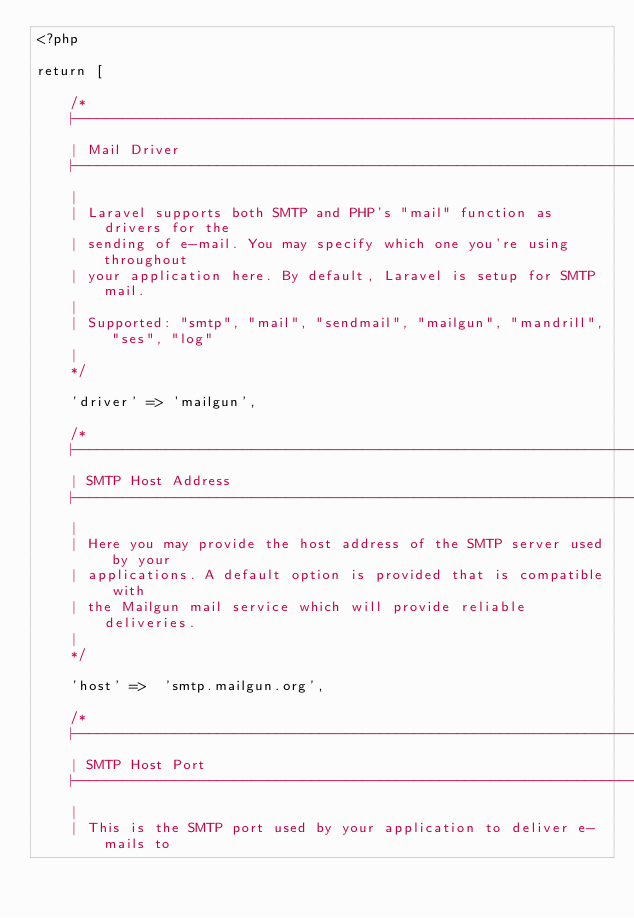Convert code to text. <code><loc_0><loc_0><loc_500><loc_500><_PHP_><?php

return [

    /*
    |--------------------------------------------------------------------------
    | Mail Driver
    |--------------------------------------------------------------------------
    |
    | Laravel supports both SMTP and PHP's "mail" function as drivers for the
    | sending of e-mail. You may specify which one you're using throughout
    | your application here. By default, Laravel is setup for SMTP mail.
    |
    | Supported: "smtp", "mail", "sendmail", "mailgun", "mandrill", "ses", "log"
    |
    */

    'driver' => 'mailgun',

    /*
    |--------------------------------------------------------------------------
    | SMTP Host Address
    |--------------------------------------------------------------------------
    |
    | Here you may provide the host address of the SMTP server used by your
    | applications. A default option is provided that is compatible with
    | the Mailgun mail service which will provide reliable deliveries.
    |
    */

    'host' =>  'smtp.mailgun.org',

    /*
    |--------------------------------------------------------------------------
    | SMTP Host Port
    |--------------------------------------------------------------------------
    |
    | This is the SMTP port used by your application to deliver e-mails to</code> 